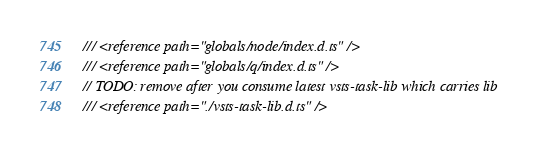<code> <loc_0><loc_0><loc_500><loc_500><_TypeScript_>/// <reference path="globals/node/index.d.ts" />
/// <reference path="globals/q/index.d.ts" />
// TODO: remove after you consume latest vsts-task-lib which carries lib
/// <reference path="./vsts-task-lib.d.ts" />
</code> 